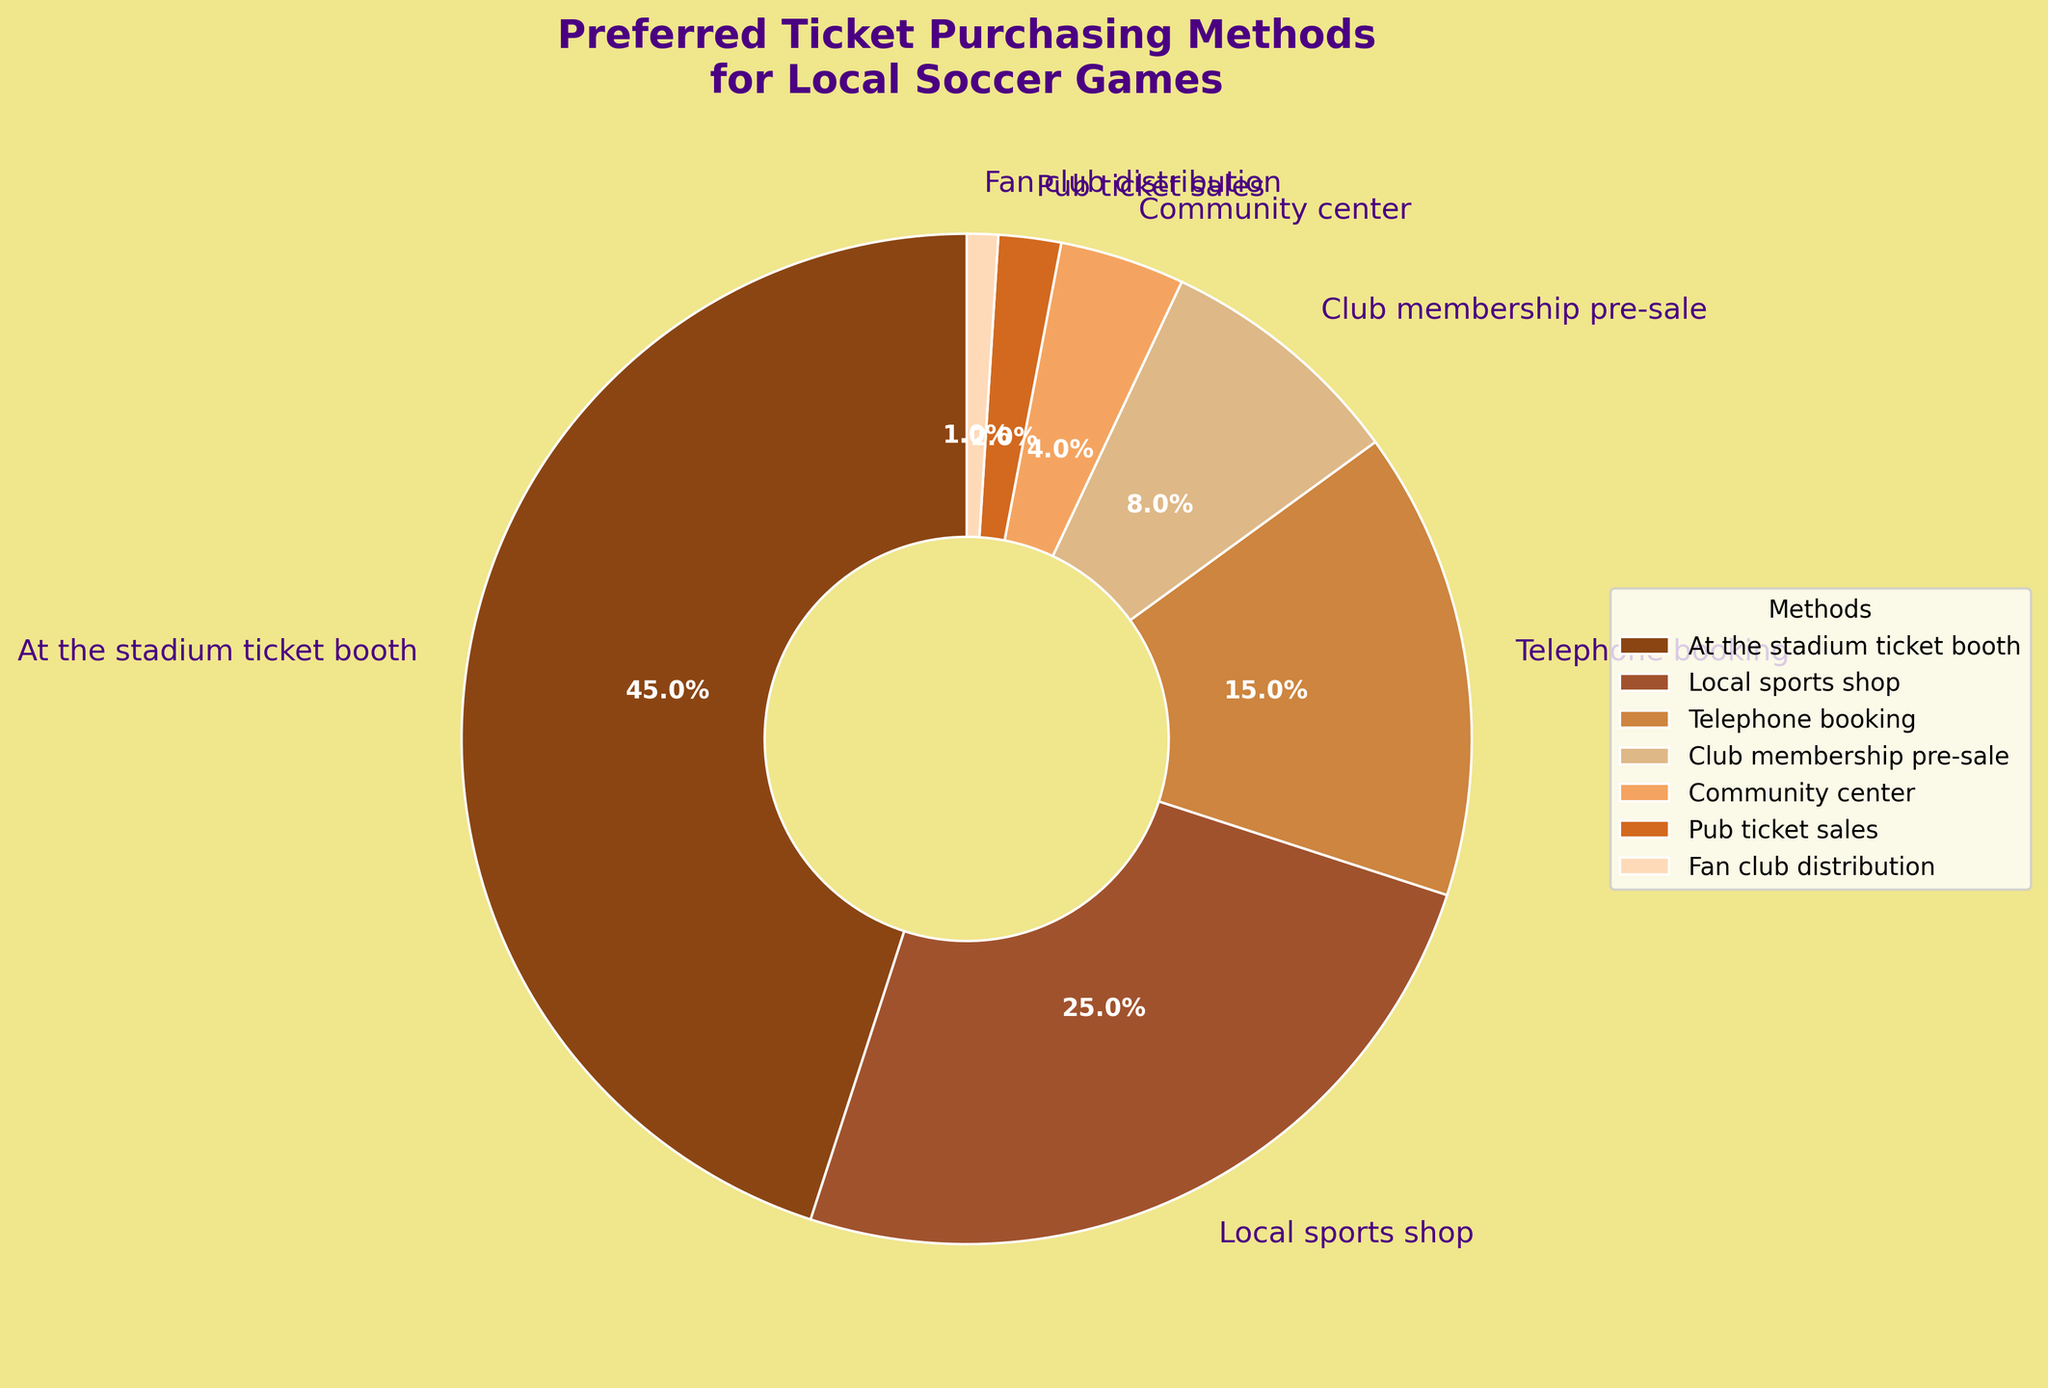What's the most preferred method for purchasing tickets for local soccer games? According to the pie chart, the largest segment represents purchasing tickets at the stadium ticket booth, which is 45%.
Answer: At the stadium ticket booth Which method is the least preferred for purchasing tickets? The smallest slice in the pie chart corresponds to fan club distribution, with only 1%.
Answer: Fan club distribution How much more popular is purchasing tickets at the stadium ticket booth compared to at a local sports shop? The segment for the stadium ticket booth is 45%, while that for the local sports shop is 25%. 45% - 25% = 20%.
Answer: 20% What is the combined percentage for purchasing tickets at a pub and through fan clubs? The percentage for pub ticket sales is 2%, and for fan club distribution, it is 1%. 2% + 1% = 3%.
Answer: 3% Compare the popularity of telephone booking and club membership pre-sale? The telephone booking method accounts for 15% and club membership pre-sale represents 8%. Telephone booking is 7% more popular than club membership pre-sale.
Answer: Telephone booking is 7% more popular Are community center sales or club membership pre-sales more preferred? The percentage for community center sales is 4%, while for club membership pre-sales it is 8%. Club membership pre-sale is more preferred.
Answer: Club membership pre-sales Which methods exceed a 20% share? The segments for purchasing tickets at the stadium ticket booth and at local sports shops are greater than 20%, with 45% and 25%, respectively.
Answer: At the stadium ticket booth and local sports shop What percentage of fans prefer to buy tickets in ways other than at the stadium ticket booth? The stadium ticket booth accounts for 45%. Thus, 100% - 45% = 55% prefer other methods.
Answer: 55% Which visual attributes help differentiate methods of ticket purchasing? Different colors indicate different methods, and the size of each segment relative to one another shows the popularity. Larger segments indicate more preferred methods, labeled with their percentages.
Answer: Colors and segment sizes 